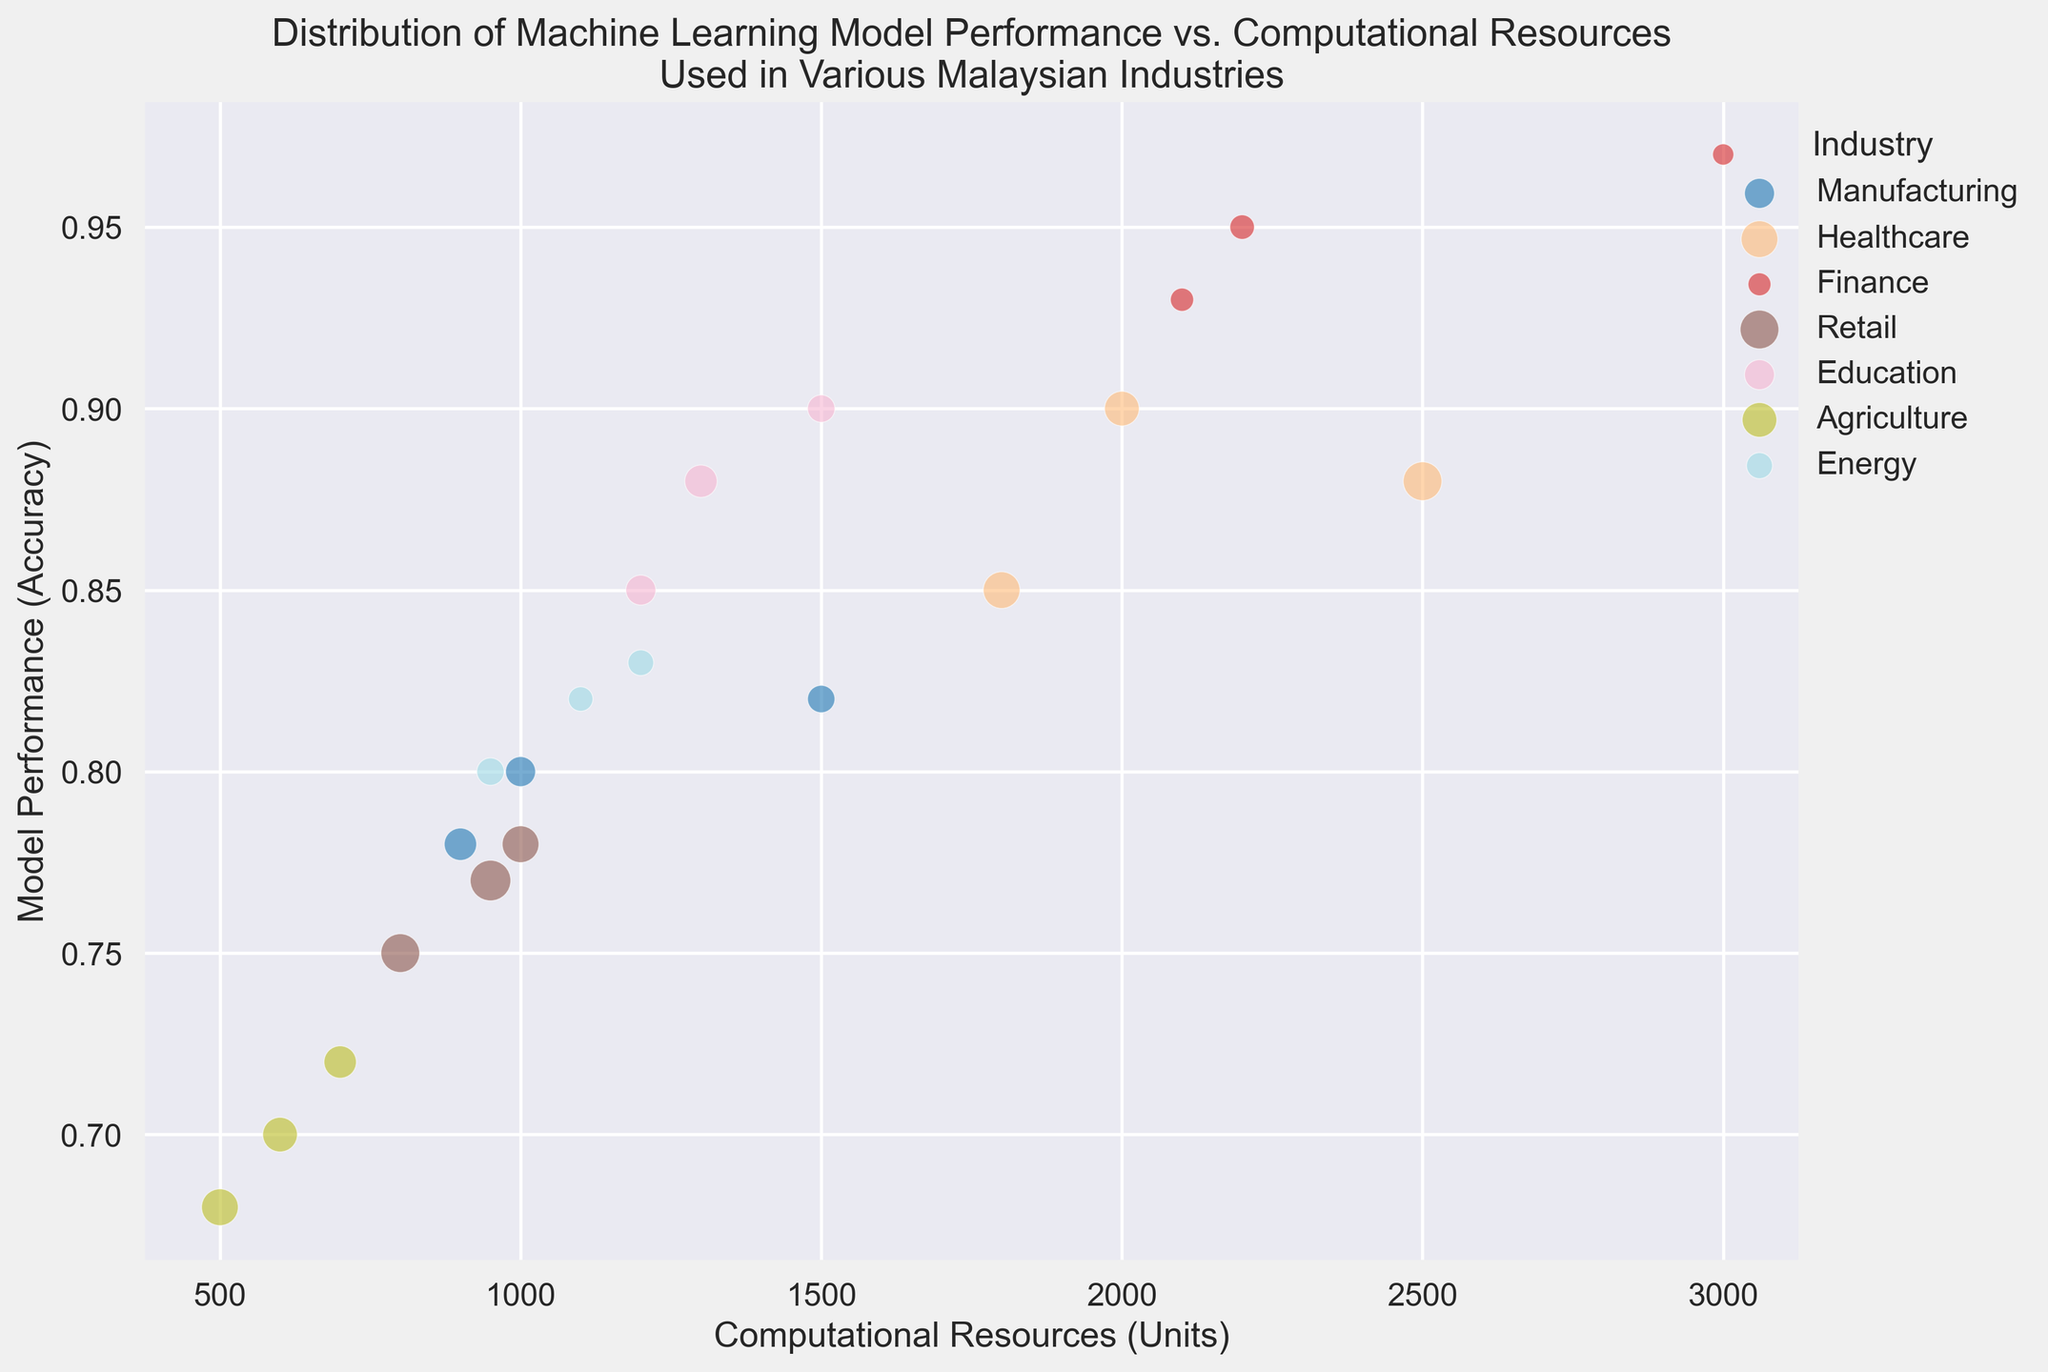What is the industry with the highest model performance? The highest model performance appears to be approximately 0.97. Comparing the model performances across different industries, Finance has the highest value.
Answer: Finance Which industry requires the most computational resources for their models? The highest value on the computational resources axis is 3000 units. Checking the chart, the industry associated with this value is Finance.
Answer: Finance What is the average model performance of the Healthcare and Education industries? Healthcare has values of 0.9, 0.85, 0.88 and Education has 0.85, 0.88, 0.9. Summing these gives 0.9+0.85+0.88+0.85+0.88+0.9 = 5.26. Dividing by the number of entries, 6, gives an average of 5.26/6 ≈ 0.88.
Answer: 0.88 Which industry demonstrates the largest spread in computational resources? Looking at the x-axis range for each industry, Agriculture ranges from 500 to 700, a spread of 200. In contrast, Finance ranges from 2100 to 3000, a spread of 900. Therefore, Finance has the largest spread.
Answer: Finance Which industry cluster has the largest number of data points or bubbles? Counting the bubbles, Healthcare has the highest, with 3 distinct points of model performance shown.
Answer: Healthcare What is the difference in average model performance between the Manufacturing and Energy industries? Manufacturing: (0.8+0.82+0.78)/3 = 0.8. Energy: (0.82+0.80+0.83)/3 ≈ 0.8167. The difference: 0.8167 - 0.8 ≈ 0.0167.
Answer: 0.0167 Which industry shows the least frequency of data points? Size of bubbles represents frequency. The smallest bubbles appear in the Energy and Finance industries. Since energy has bubbles of sizes 20, 25, and 22, Finance has bubbles of count 18, 20, and 15. Finance shows the least frequency.
Answer: Finance How does the model performance of Retail industry compare to that of Agriculture? Retail model performance ranges from 0.75 to 0.78, while Agriculture ranges from 0.68 to 0.72. Retail generally shows higher model performance.
Answer: Retail Considering bubbles' sizes, which industry appears to utilize the most consistent computational resources? Consistency in computational resources is indicated by closely clustered bubbles along the x-axis. Both Retail and Agriculture show closely clustered bubbles, but Retail seems more so with ranges from 800 to 1000 compared to Agriculture's 500 to 700.
Answer: Retail What is the approximate total frequency of data points in Manufacturing? From chart, Manufacturing has frequencies 30, 25, and 35. Summing them, 30 + 25 + 35 = 90.
Answer: 90 